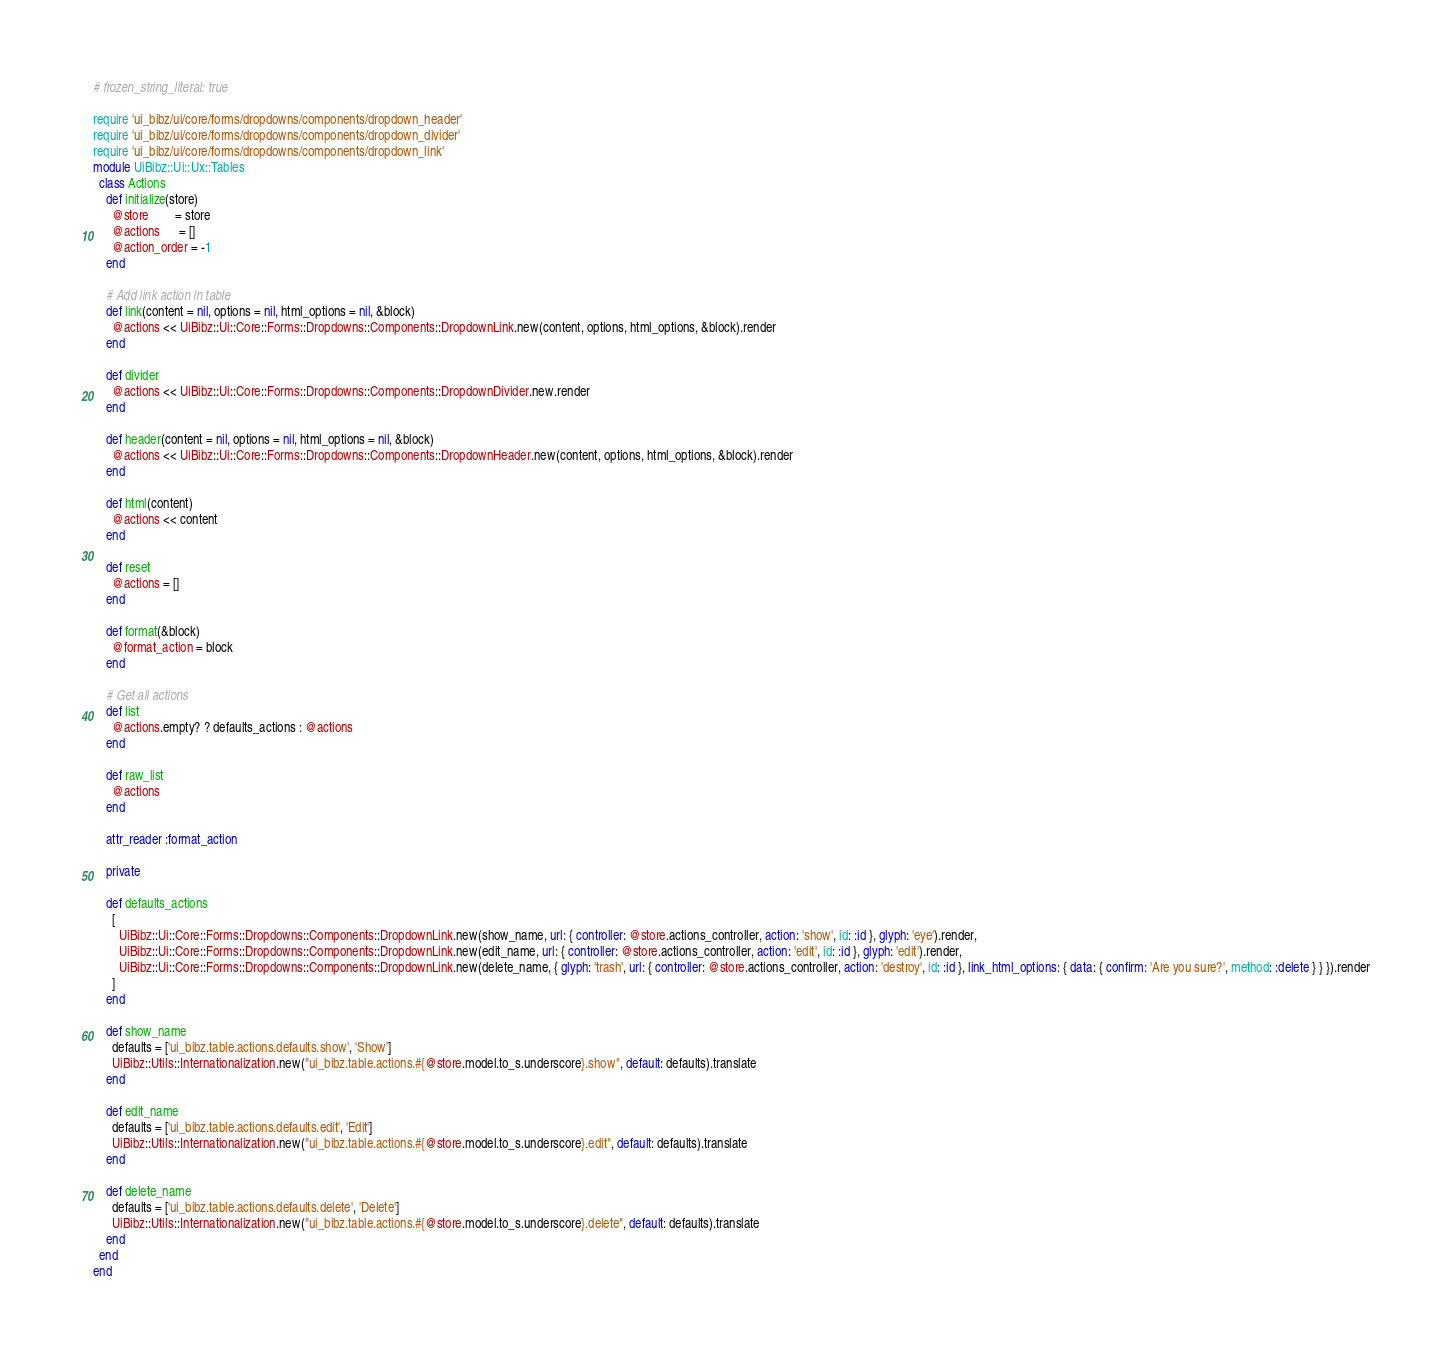<code> <loc_0><loc_0><loc_500><loc_500><_Ruby_># frozen_string_literal: true

require 'ui_bibz/ui/core/forms/dropdowns/components/dropdown_header'
require 'ui_bibz/ui/core/forms/dropdowns/components/dropdown_divider'
require 'ui_bibz/ui/core/forms/dropdowns/components/dropdown_link'
module UiBibz::Ui::Ux::Tables
  class Actions
    def initialize(store)
      @store        = store
      @actions      = []
      @action_order = -1
    end

    # Add link action in table
    def link(content = nil, options = nil, html_options = nil, &block)
      @actions << UiBibz::Ui::Core::Forms::Dropdowns::Components::DropdownLink.new(content, options, html_options, &block).render
    end

    def divider
      @actions << UiBibz::Ui::Core::Forms::Dropdowns::Components::DropdownDivider.new.render
    end

    def header(content = nil, options = nil, html_options = nil, &block)
      @actions << UiBibz::Ui::Core::Forms::Dropdowns::Components::DropdownHeader.new(content, options, html_options, &block).render
    end

    def html(content)
      @actions << content
    end

    def reset
      @actions = []
    end

    def format(&block)
      @format_action = block
    end

    # Get all actions
    def list
      @actions.empty? ? defaults_actions : @actions
    end

    def raw_list
      @actions
    end

    attr_reader :format_action

    private

    def defaults_actions
      [
        UiBibz::Ui::Core::Forms::Dropdowns::Components::DropdownLink.new(show_name, url: { controller: @store.actions_controller, action: 'show', id: :id }, glyph: 'eye').render,
        UiBibz::Ui::Core::Forms::Dropdowns::Components::DropdownLink.new(edit_name, url: { controller: @store.actions_controller, action: 'edit', id: :id }, glyph: 'edit').render,
        UiBibz::Ui::Core::Forms::Dropdowns::Components::DropdownLink.new(delete_name, { glyph: 'trash', url: { controller: @store.actions_controller, action: 'destroy', id: :id }, link_html_options: { data: { confirm: 'Are you sure?', method: :delete } } }).render
      ]
    end

    def show_name
      defaults = ['ui_bibz.table.actions.defaults.show', 'Show']
      UiBibz::Utils::Internationalization.new("ui_bibz.table.actions.#{@store.model.to_s.underscore}.show", default: defaults).translate
    end

    def edit_name
      defaults = ['ui_bibz.table.actions.defaults.edit', 'Edit']
      UiBibz::Utils::Internationalization.new("ui_bibz.table.actions.#{@store.model.to_s.underscore}.edit", default: defaults).translate
    end

    def delete_name
      defaults = ['ui_bibz.table.actions.defaults.delete', 'Delete']
      UiBibz::Utils::Internationalization.new("ui_bibz.table.actions.#{@store.model.to_s.underscore}.delete", default: defaults).translate
    end
  end
end
</code> 